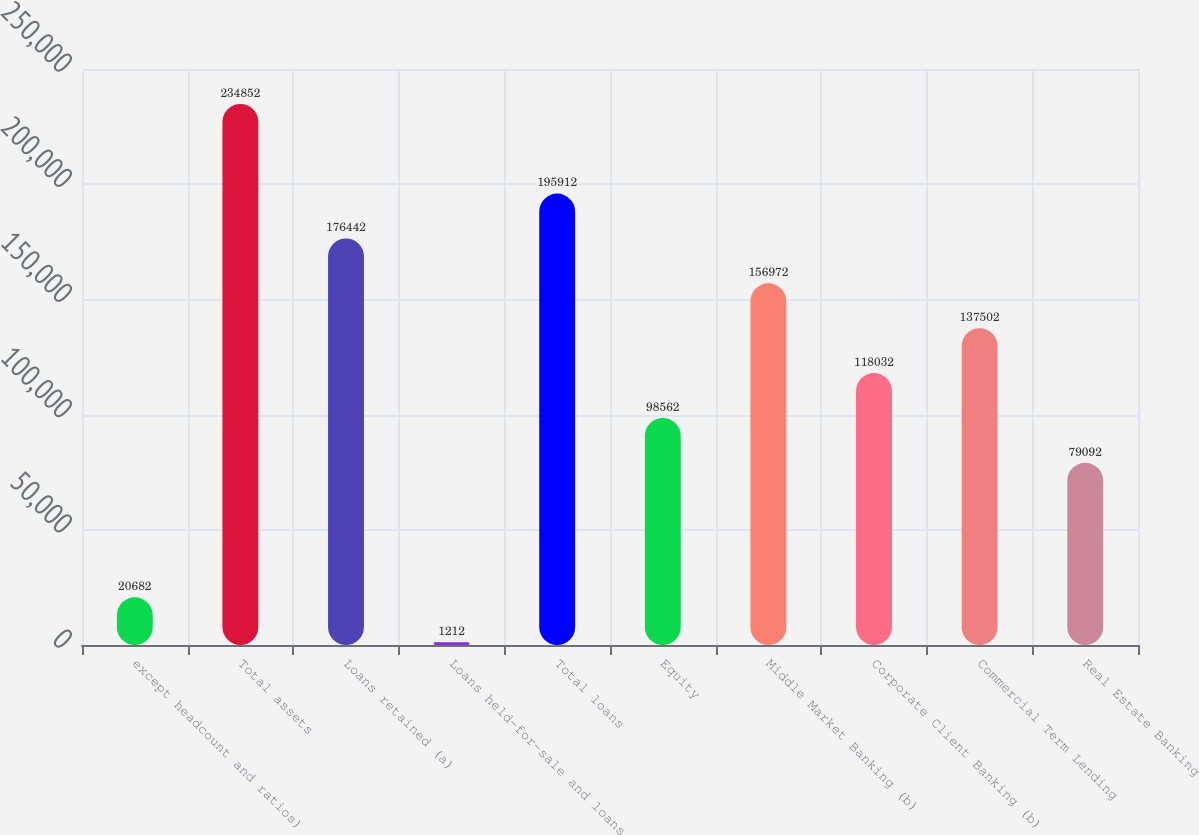<chart> <loc_0><loc_0><loc_500><loc_500><bar_chart><fcel>except headcount and ratios)<fcel>Total assets<fcel>Loans retained (a)<fcel>Loans held-for-sale and loans<fcel>Total loans<fcel>Equity<fcel>Middle Market Banking (b)<fcel>Corporate Client Banking (b)<fcel>Commercial Term Lending<fcel>Real Estate Banking<nl><fcel>20682<fcel>234852<fcel>176442<fcel>1212<fcel>195912<fcel>98562<fcel>156972<fcel>118032<fcel>137502<fcel>79092<nl></chart> 